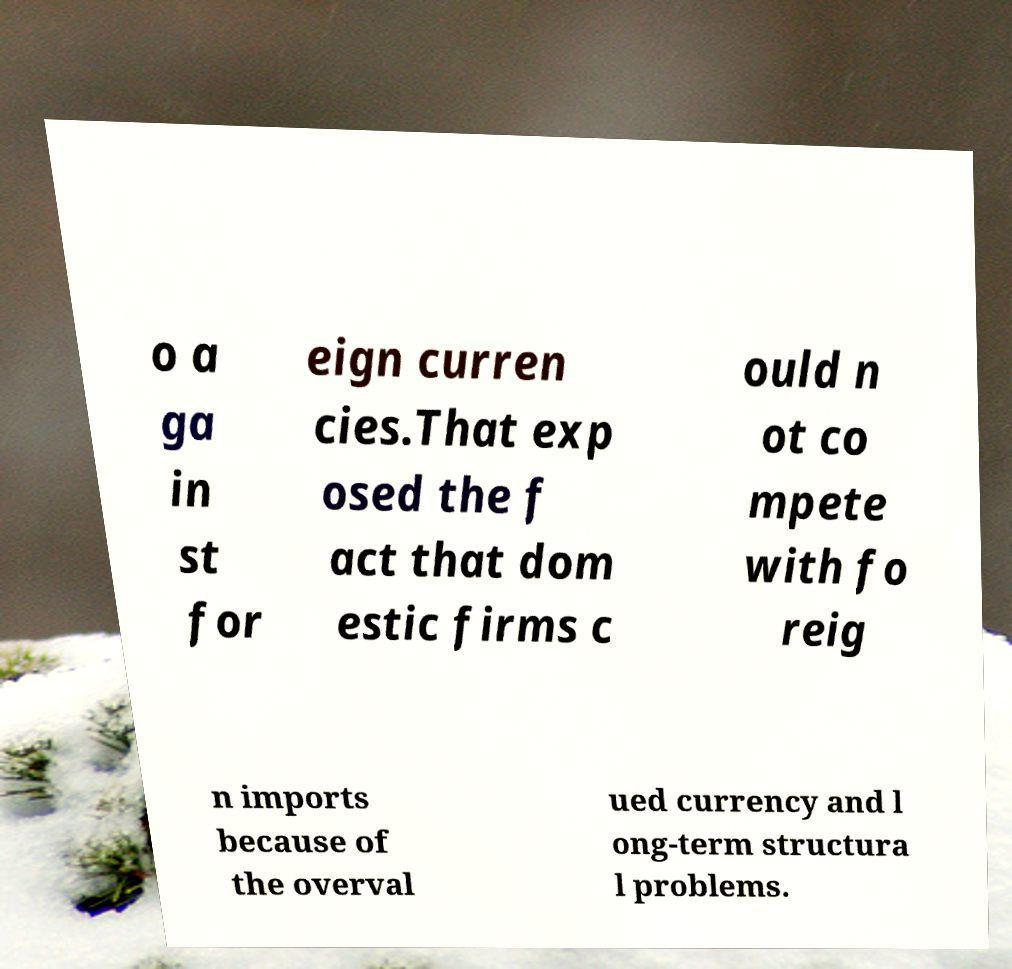What messages or text are displayed in this image? I need them in a readable, typed format. o a ga in st for eign curren cies.That exp osed the f act that dom estic firms c ould n ot co mpete with fo reig n imports because of the overval ued currency and l ong-term structura l problems. 